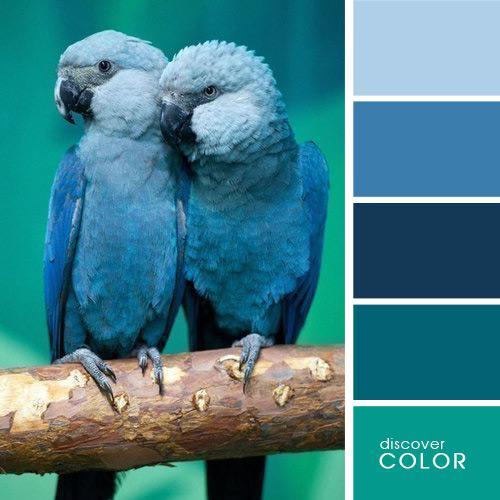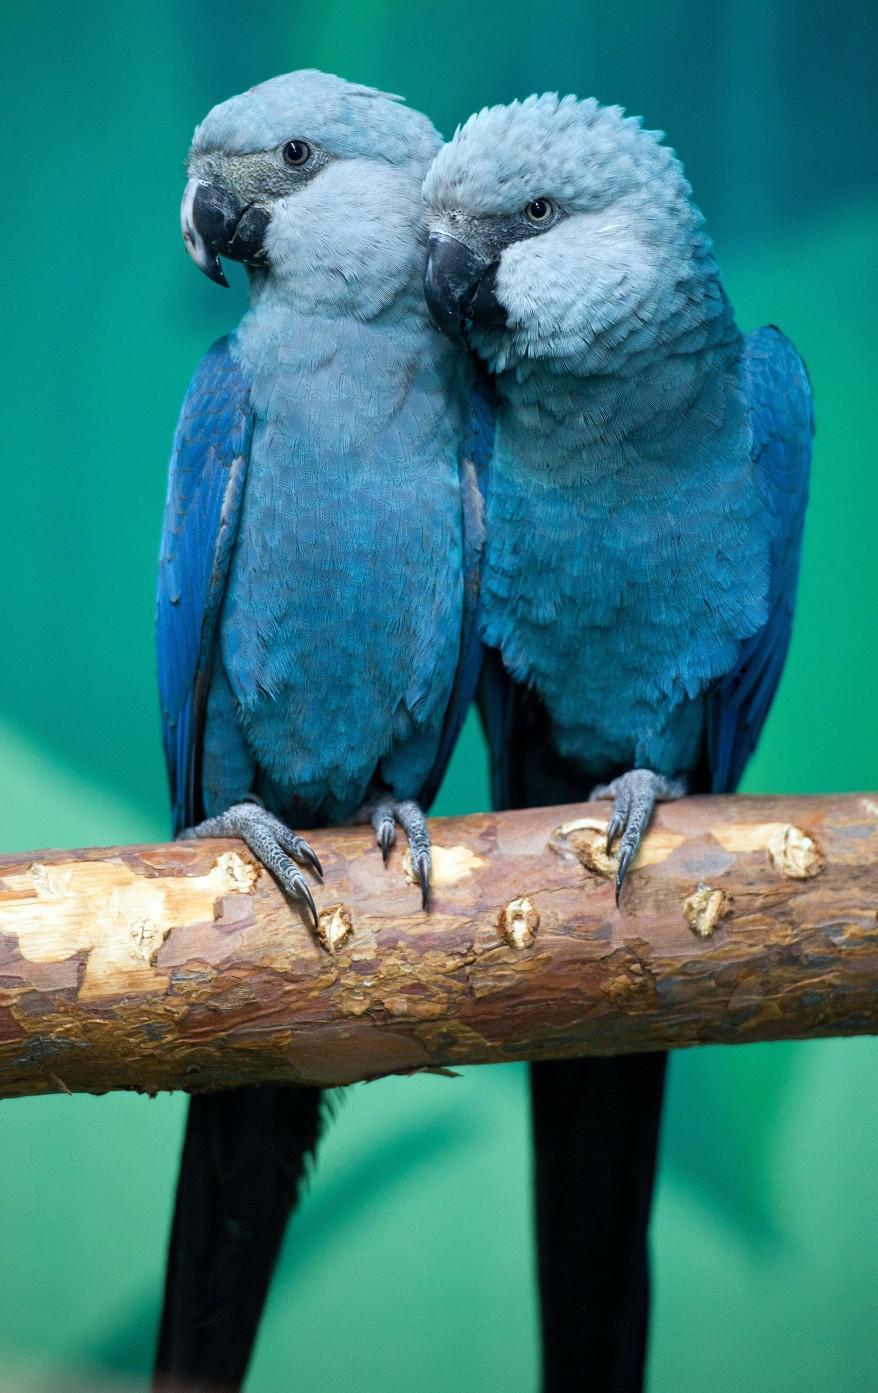The first image is the image on the left, the second image is the image on the right. For the images displayed, is the sentence "All of the birds sit on a branch with a blue background behind them." factually correct? Answer yes or no. Yes. 